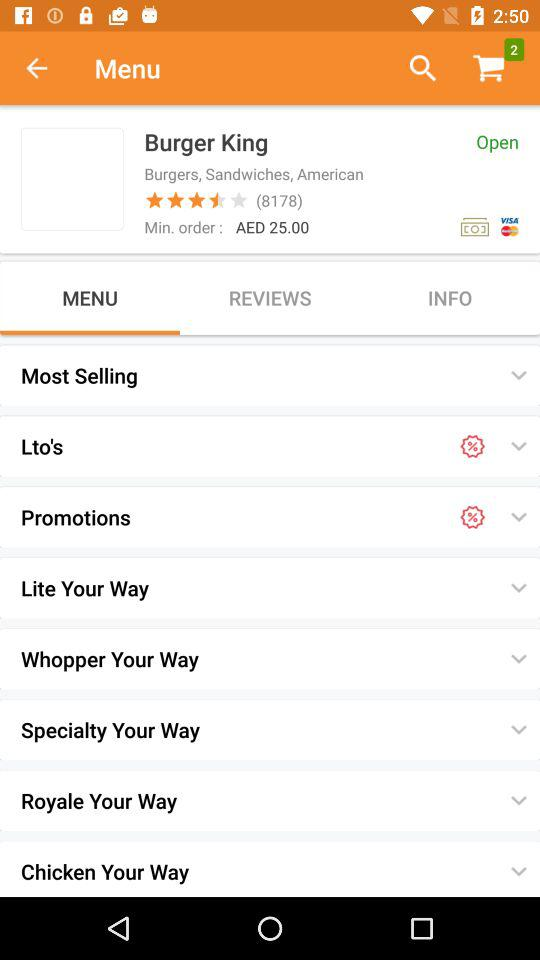How much is the minimum order?
Answer the question using a single word or phrase. AED 25.00 